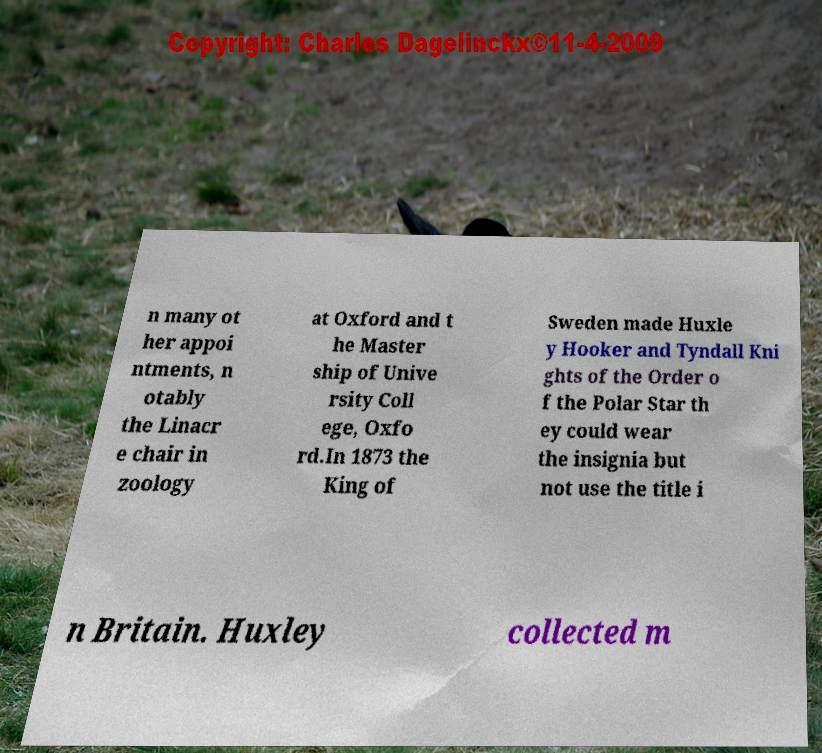I need the written content from this picture converted into text. Can you do that? n many ot her appoi ntments, n otably the Linacr e chair in zoology at Oxford and t he Master ship of Unive rsity Coll ege, Oxfo rd.In 1873 the King of Sweden made Huxle y Hooker and Tyndall Kni ghts of the Order o f the Polar Star th ey could wear the insignia but not use the title i n Britain. Huxley collected m 